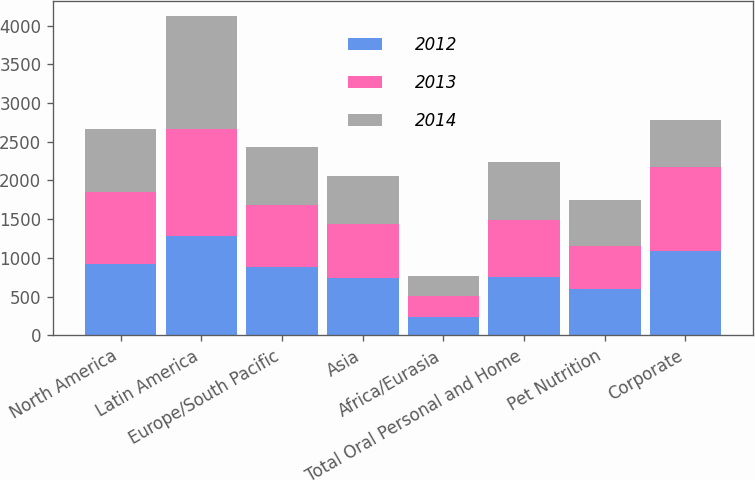<chart> <loc_0><loc_0><loc_500><loc_500><stacked_bar_chart><ecel><fcel>North America<fcel>Latin America<fcel>Europe/South Pacific<fcel>Asia<fcel>Africa/Eurasia<fcel>Total Oral Personal and Home<fcel>Pet Nutrition<fcel>Corporate<nl><fcel>2012<fcel>926<fcel>1279<fcel>877<fcel>736<fcel>235<fcel>747<fcel>592<fcel>1088<nl><fcel>2013<fcel>927<fcel>1385<fcel>805<fcel>698<fcel>268<fcel>747<fcel>563<fcel>1090<nl><fcel>2014<fcel>810<fcel>1454<fcel>747<fcel>619<fcel>267<fcel>747<fcel>589<fcel>597<nl></chart> 